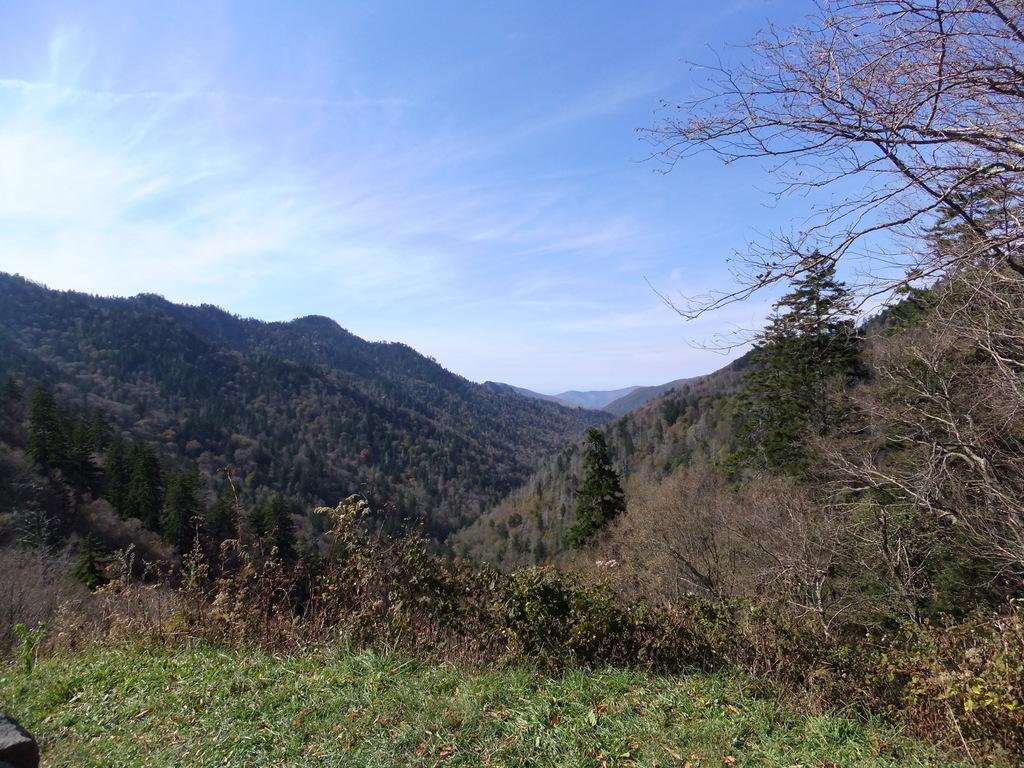How would you summarize this image in a sentence or two? In this image I see the plants in the front. In the background I see lot of trees, mountains and the sky. 